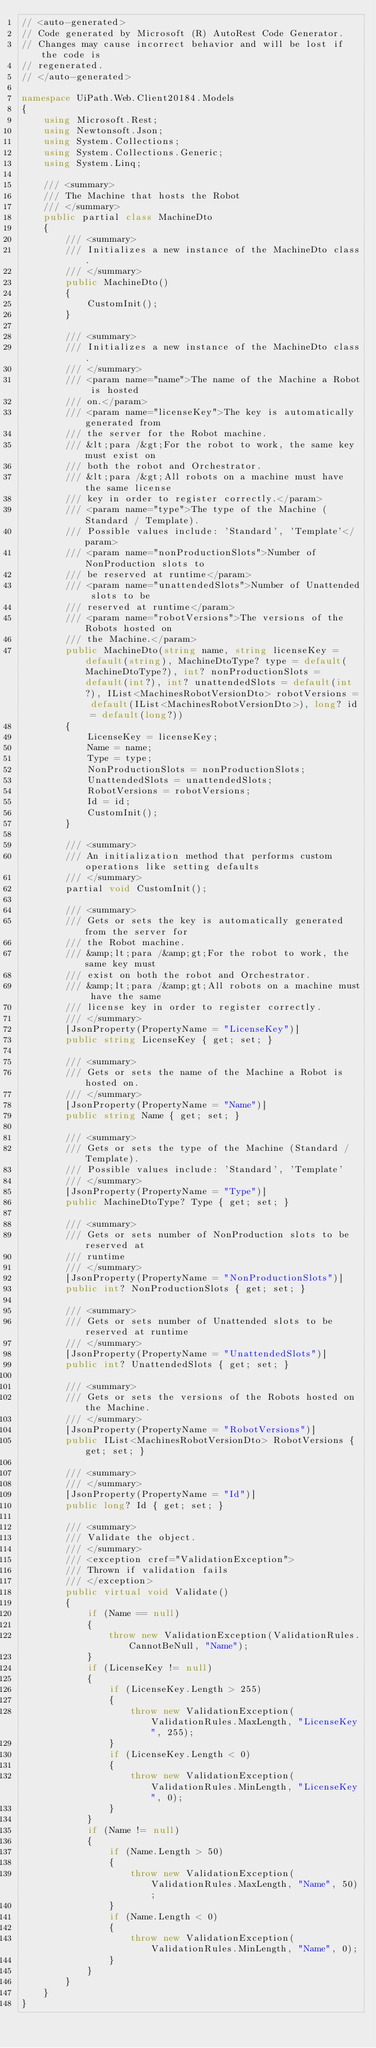<code> <loc_0><loc_0><loc_500><loc_500><_C#_>// <auto-generated>
// Code generated by Microsoft (R) AutoRest Code Generator.
// Changes may cause incorrect behavior and will be lost if the code is
// regenerated.
// </auto-generated>

namespace UiPath.Web.Client20184.Models
{
    using Microsoft.Rest;
    using Newtonsoft.Json;
    using System.Collections;
    using System.Collections.Generic;
    using System.Linq;

    /// <summary>
    /// The Machine that hosts the Robot
    /// </summary>
    public partial class MachineDto
    {
        /// <summary>
        /// Initializes a new instance of the MachineDto class.
        /// </summary>
        public MachineDto()
        {
            CustomInit();
        }

        /// <summary>
        /// Initializes a new instance of the MachineDto class.
        /// </summary>
        /// <param name="name">The name of the Machine a Robot is hosted
        /// on.</param>
        /// <param name="licenseKey">The key is automatically generated from
        /// the server for the Robot machine.
        /// &lt;para /&gt;For the robot to work, the same key must exist on
        /// both the robot and Orchestrator.
        /// &lt;para /&gt;All robots on a machine must have the same license
        /// key in order to register correctly.</param>
        /// <param name="type">The type of the Machine (Standard / Template).
        /// Possible values include: 'Standard', 'Template'</param>
        /// <param name="nonProductionSlots">Number of NonProduction slots to
        /// be reserved at runtime</param>
        /// <param name="unattendedSlots">Number of Unattended slots to be
        /// reserved at runtime</param>
        /// <param name="robotVersions">The versions of the Robots hosted on
        /// the Machine.</param>
        public MachineDto(string name, string licenseKey = default(string), MachineDtoType? type = default(MachineDtoType?), int? nonProductionSlots = default(int?), int? unattendedSlots = default(int?), IList<MachinesRobotVersionDto> robotVersions = default(IList<MachinesRobotVersionDto>), long? id = default(long?))
        {
            LicenseKey = licenseKey;
            Name = name;
            Type = type;
            NonProductionSlots = nonProductionSlots;
            UnattendedSlots = unattendedSlots;
            RobotVersions = robotVersions;
            Id = id;
            CustomInit();
        }

        /// <summary>
        /// An initialization method that performs custom operations like setting defaults
        /// </summary>
        partial void CustomInit();

        /// <summary>
        /// Gets or sets the key is automatically generated from the server for
        /// the Robot machine.
        /// &amp;lt;para /&amp;gt;For the robot to work, the same key must
        /// exist on both the robot and Orchestrator.
        /// &amp;lt;para /&amp;gt;All robots on a machine must have the same
        /// license key in order to register correctly.
        /// </summary>
        [JsonProperty(PropertyName = "LicenseKey")]
        public string LicenseKey { get; set; }

        /// <summary>
        /// Gets or sets the name of the Machine a Robot is hosted on.
        /// </summary>
        [JsonProperty(PropertyName = "Name")]
        public string Name { get; set; }

        /// <summary>
        /// Gets or sets the type of the Machine (Standard / Template).
        /// Possible values include: 'Standard', 'Template'
        /// </summary>
        [JsonProperty(PropertyName = "Type")]
        public MachineDtoType? Type { get; set; }

        /// <summary>
        /// Gets or sets number of NonProduction slots to be reserved at
        /// runtime
        /// </summary>
        [JsonProperty(PropertyName = "NonProductionSlots")]
        public int? NonProductionSlots { get; set; }

        /// <summary>
        /// Gets or sets number of Unattended slots to be reserved at runtime
        /// </summary>
        [JsonProperty(PropertyName = "UnattendedSlots")]
        public int? UnattendedSlots { get; set; }

        /// <summary>
        /// Gets or sets the versions of the Robots hosted on the Machine.
        /// </summary>
        [JsonProperty(PropertyName = "RobotVersions")]
        public IList<MachinesRobotVersionDto> RobotVersions { get; set; }

        /// <summary>
        /// </summary>
        [JsonProperty(PropertyName = "Id")]
        public long? Id { get; set; }

        /// <summary>
        /// Validate the object.
        /// </summary>
        /// <exception cref="ValidationException">
        /// Thrown if validation fails
        /// </exception>
        public virtual void Validate()
        {
            if (Name == null)
            {
                throw new ValidationException(ValidationRules.CannotBeNull, "Name");
            }
            if (LicenseKey != null)
            {
                if (LicenseKey.Length > 255)
                {
                    throw new ValidationException(ValidationRules.MaxLength, "LicenseKey", 255);
                }
                if (LicenseKey.Length < 0)
                {
                    throw new ValidationException(ValidationRules.MinLength, "LicenseKey", 0);
                }
            }
            if (Name != null)
            {
                if (Name.Length > 50)
                {
                    throw new ValidationException(ValidationRules.MaxLength, "Name", 50);
                }
                if (Name.Length < 0)
                {
                    throw new ValidationException(ValidationRules.MinLength, "Name", 0);
                }
            }
        }
    }
}
</code> 